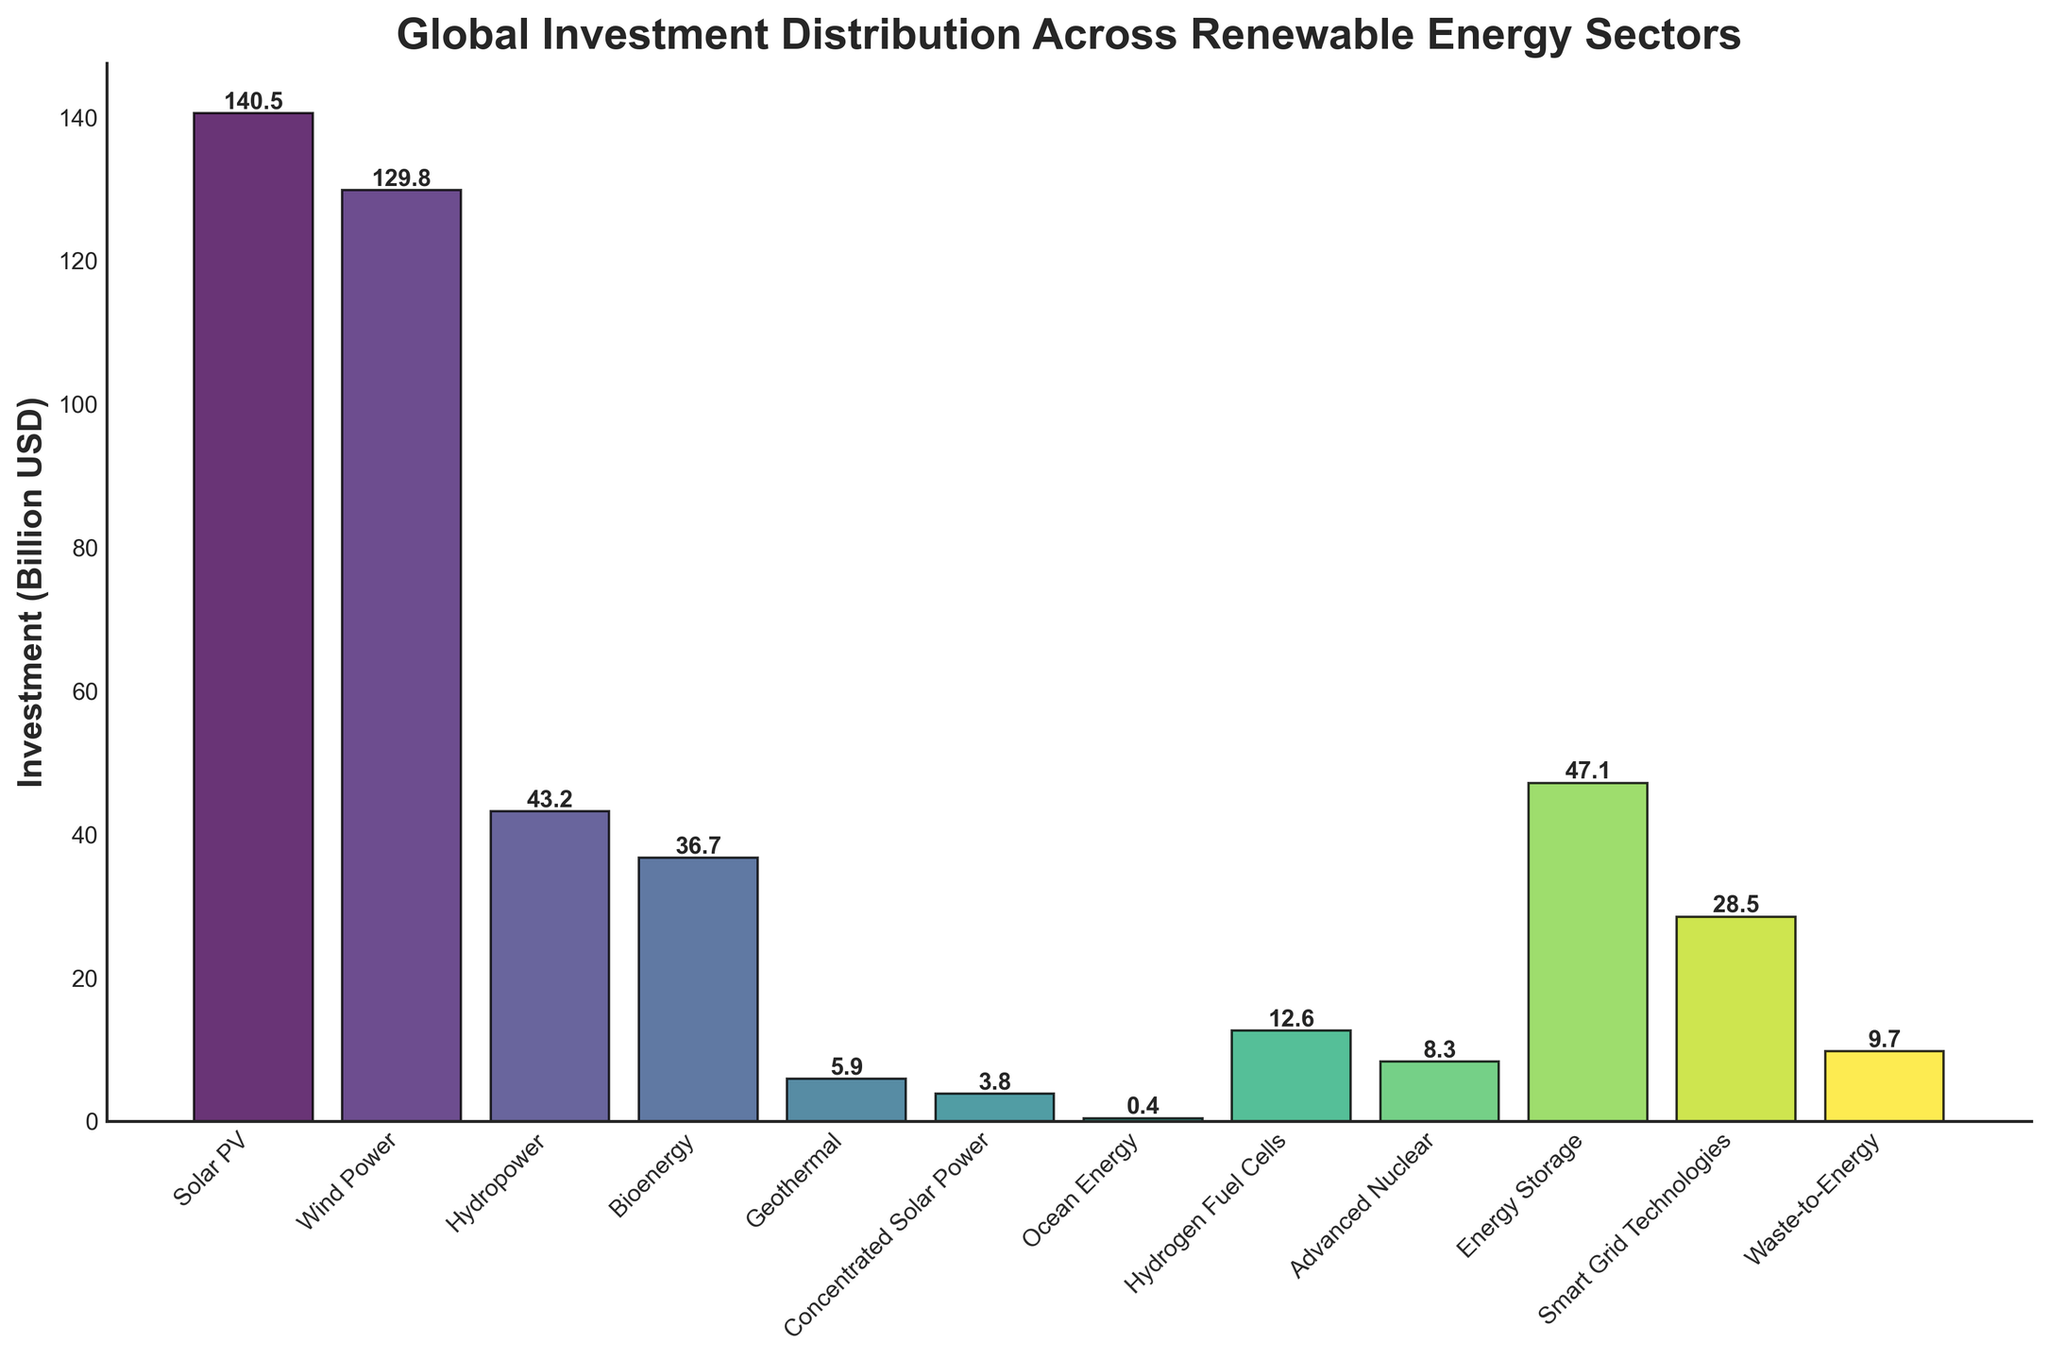Which renewable energy sector received the highest investment? The bar with the greatest height represents the sector with the highest investment. By observing the heights of all the bars, the 'Solar PV' sector clearly has the tallest bar.
Answer: Solar PV Which sectors have investments greater than 100 billion USD? Look at the bars and identify those that reach above the 100 billion USD mark on the y-axis. 'Solar PV' and 'Wind Power' both have bars exceeding this threshold.
Answer: Solar PV, Wind Power Which sector has the lowest investment? Identify the bar with the shortest height, which corresponds to the sector with the lowest investment. 'Ocean Energy' has the smallest bar height.
Answer: Ocean Energy How does the investment in Bioenergy compare to that in Geothermal? Compare the heights of the bars for 'Bioenergy' (36.7 billion USD) and 'Geothermal' (5.9 billion USD). 'Bioenergy' has a significantly taller bar than 'Geothermal'.
Answer: Bioenergy is significantly higher than Geothermal Is the investment in Smart Grid Technologies higher or lower than in Hydropower? Compare the heights of the bars for 'Smart Grid Technologies' (28.5 billion USD) and 'Hydropower' (43.2 billion USD).
Answer: Smart Grid Technologies is lower than Hydropower When combining investments in Bioenergy and Hydrogen Fuel Cells, is the resulting amount greater or less than the investment in Hydropower? Add Bioenergy (36.7 billion USD) and Hydrogen Fuel Cells (12.6 billion USD), then compare the sum to Hydropower (43.2 billion USD). 36.7 + 12.6 = 49.3, which is greater than 43.2
Answer: Greater 